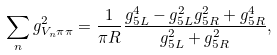<formula> <loc_0><loc_0><loc_500><loc_500>\sum _ { n } g _ { V _ { n } \pi \pi } ^ { 2 } = \frac { 1 } { \pi R } \frac { g _ { 5 L } ^ { 4 } - g _ { 5 L } ^ { 2 } g _ { 5 R } ^ { 2 } + g _ { 5 R } ^ { 4 } } { g _ { 5 L } ^ { 2 } + g _ { 5 R } ^ { 2 } } ,</formula> 